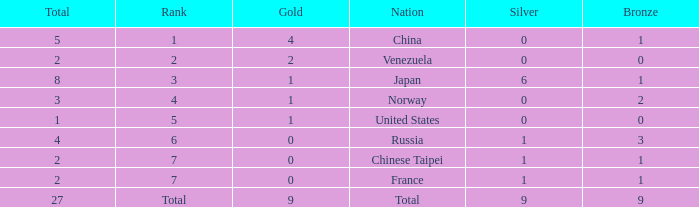What is the sum of Total when rank is 2? 2.0. 